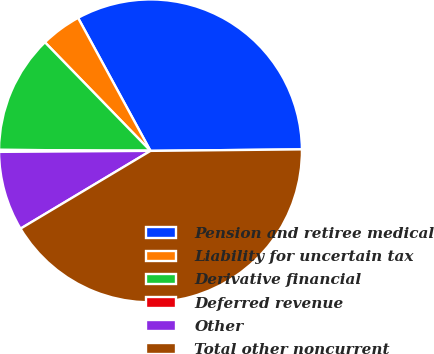Convert chart to OTSL. <chart><loc_0><loc_0><loc_500><loc_500><pie_chart><fcel>Pension and retiree medical<fcel>Liability for uncertain tax<fcel>Derivative financial<fcel>Deferred revenue<fcel>Other<fcel>Total other noncurrent<nl><fcel>32.78%<fcel>4.34%<fcel>12.62%<fcel>0.21%<fcel>8.48%<fcel>41.58%<nl></chart> 